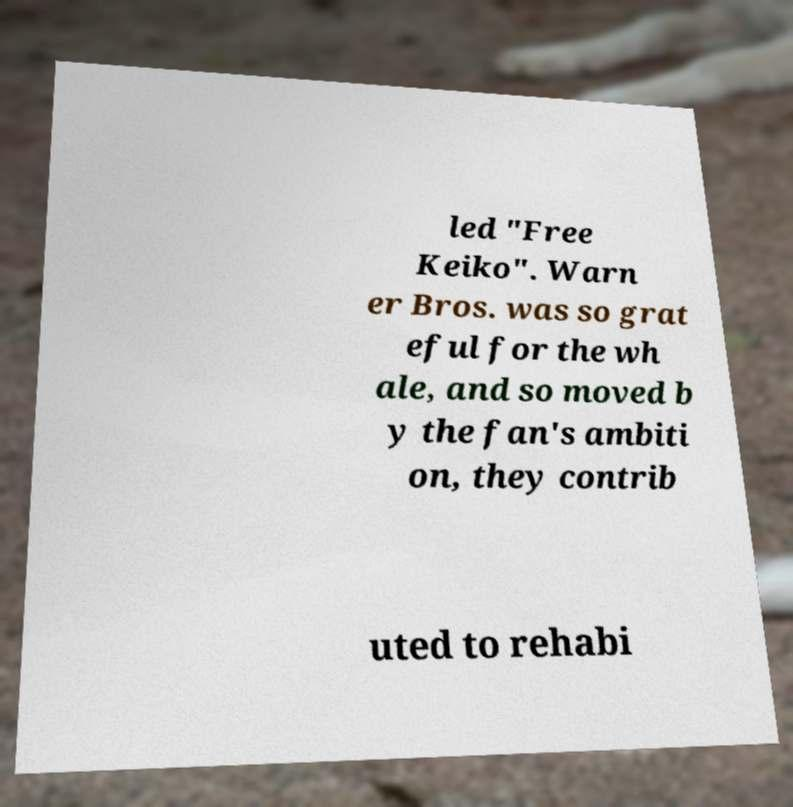Could you assist in decoding the text presented in this image and type it out clearly? led "Free Keiko". Warn er Bros. was so grat eful for the wh ale, and so moved b y the fan's ambiti on, they contrib uted to rehabi 